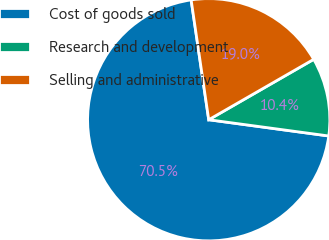<chart> <loc_0><loc_0><loc_500><loc_500><pie_chart><fcel>Cost of goods sold<fcel>Research and development<fcel>Selling and administrative<nl><fcel>70.54%<fcel>10.45%<fcel>19.01%<nl></chart> 